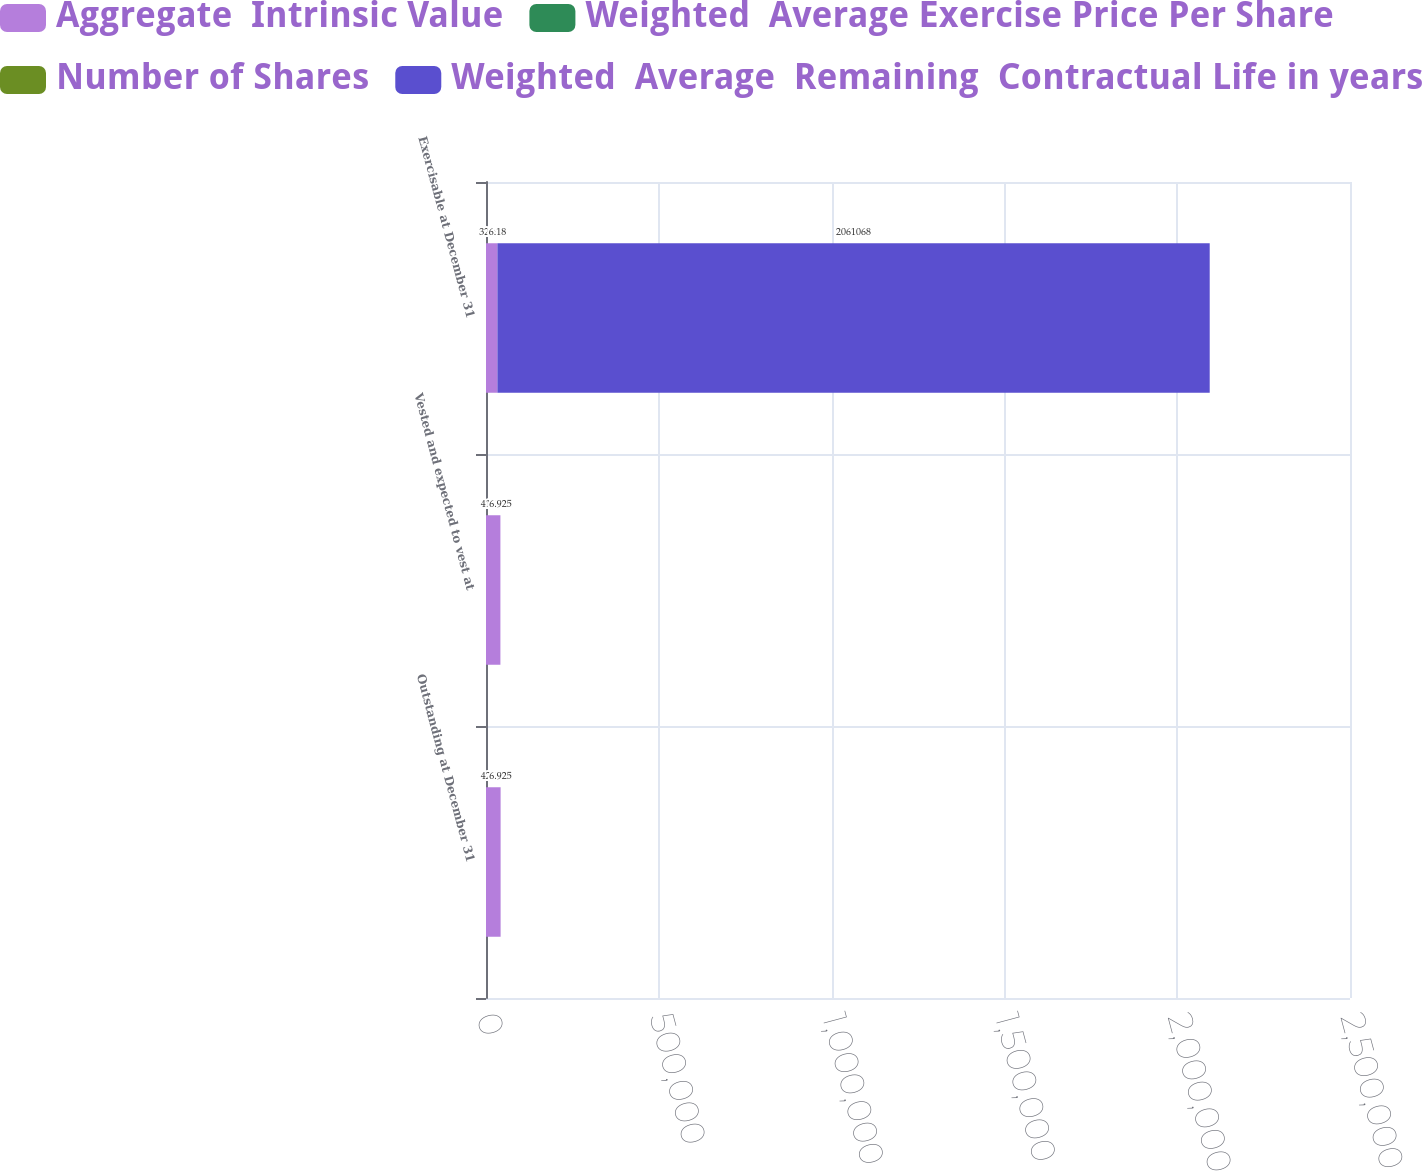Convert chart to OTSL. <chart><loc_0><loc_0><loc_500><loc_500><stacked_bar_chart><ecel><fcel>Outstanding at December 31<fcel>Vested and expected to vest at<fcel>Exercisable at December 31<nl><fcel>Aggregate  Intrinsic Value<fcel>42246<fcel>41640<fcel>32995<nl><fcel>Weighted  Average Exercise Price Per Share<fcel>1.89<fcel>1.81<fcel>1.18<nl><fcel>Number of Shares<fcel>6.47<fcel>6.45<fcel>6.18<nl><fcel>Weighted  Average  Remaining  Contractual Life in years<fcel>6.925<fcel>6.925<fcel>2.06107e+06<nl></chart> 